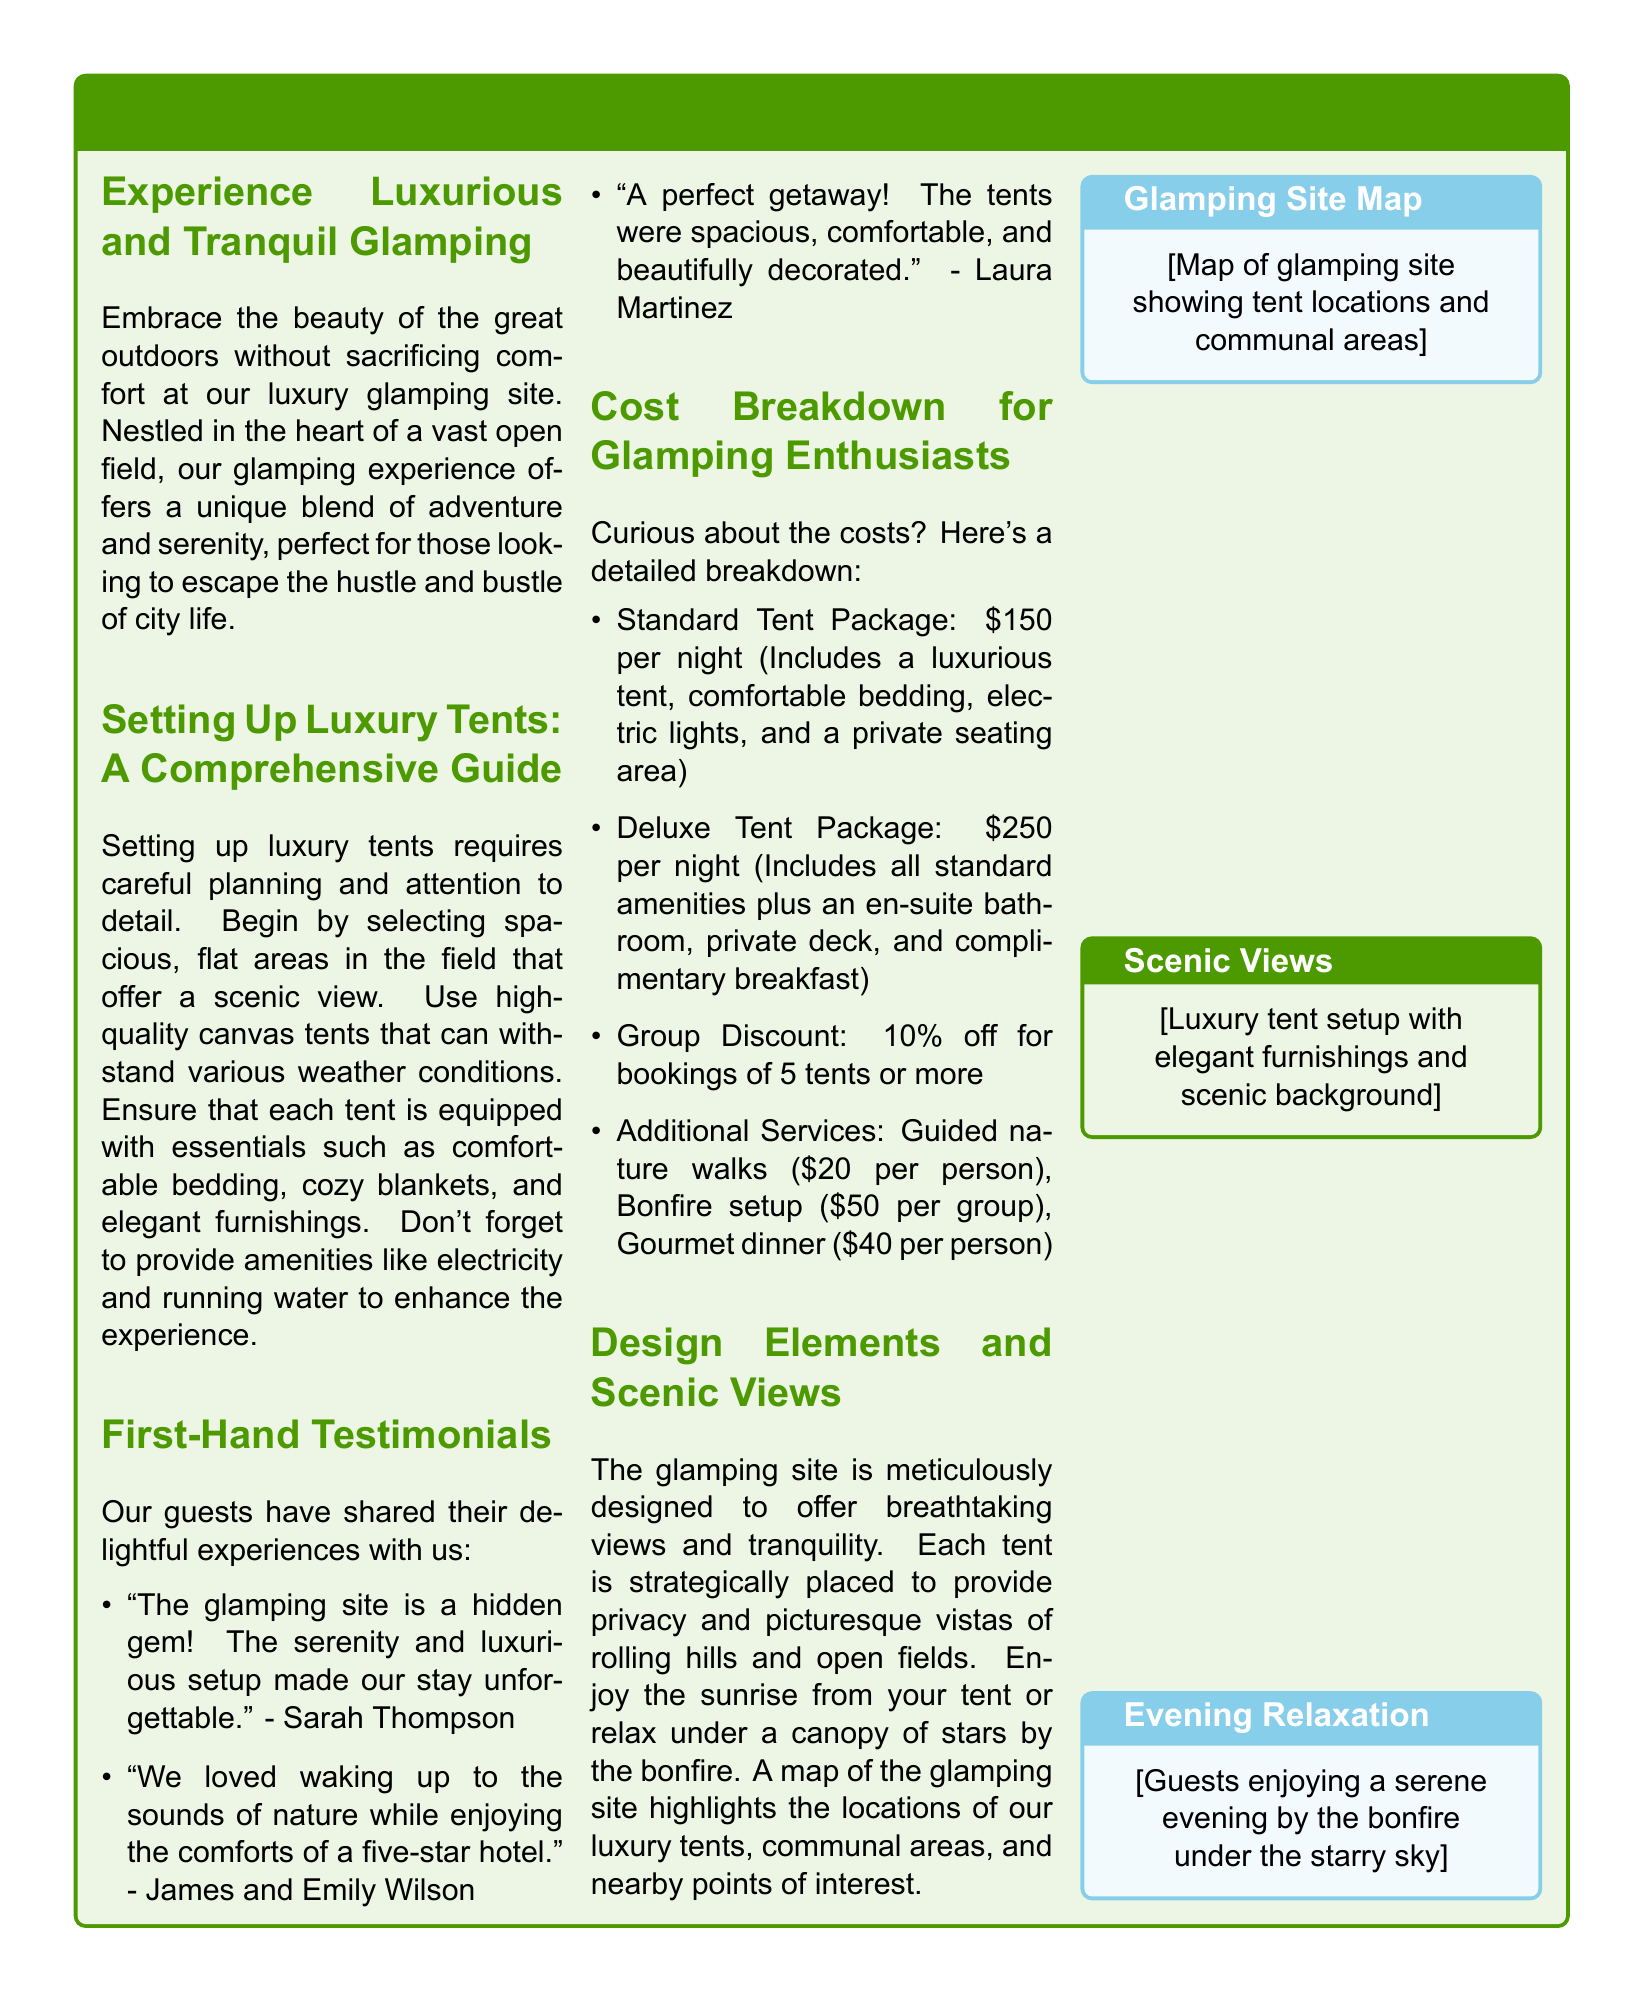What is the main theme of the article? The main theme discussed in the article is the concept of glamorous camping or 'glamping' which combines adventure and serenity in a luxurious outdoor experience.
Answer: Glamping What is included in the Standard Tent Package? The Standard Tent Package includes a luxurious tent, comfortable bedding, electric lights, and a private seating area as outlined in the cost breakdown section.
Answer: Tent, bedding, lights, seating How much does the Deluxe Tent Package cost? According to the cost breakdown section, the Deluxe Tent Package costs $250 per night.
Answer: $250 What discount is offered for group bookings? The article mentions a discount of 10% off for bookings of 5 tents or more.
Answer: 10% How do guests describe their experience in the testimonials? Guests describe their experiences as delightful, highlighting the serenity and luxurious setup of the glamping site specifically in the testimonials section.
Answer: Delightful What amenities are suggested for enhancing guests' experience in their tents? The article suggests including comfortable bedding, cozy blankets, elegant furnishings, electricity, and running water to enhance guests’ experience in the tents.
Answer: Bedding, blankets, furnishings, electricity, water How are the luxury tents positioned at the glamping site? The luxury tents are strategically placed to provide privacy and picturesque vistas of rolling hills and open fields, as detailed in the design elements section.
Answer: Strategically placed What activity is available for guests at an additional cost? The article mentions guided nature walks as one of the additional services available for guests at an extra charge.
Answer: Guided nature walks 